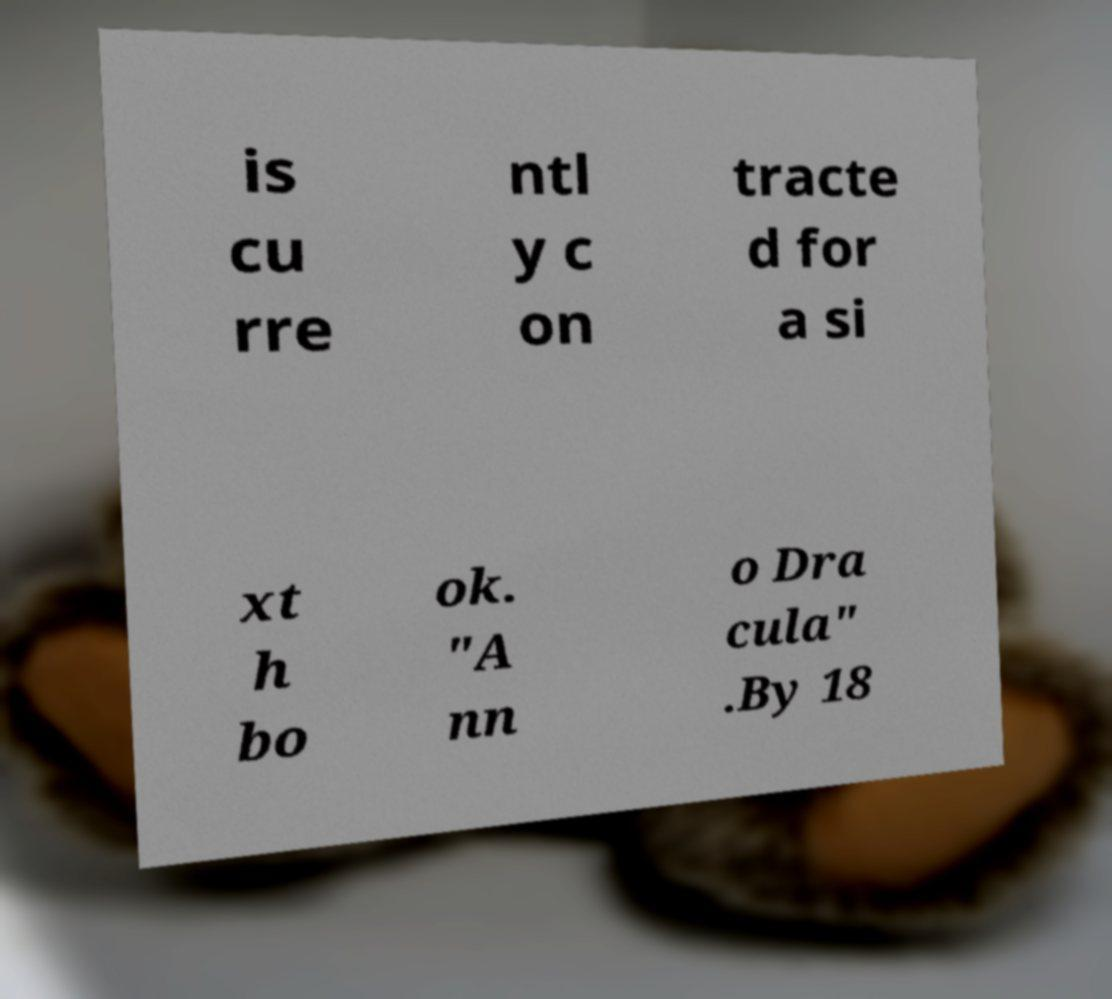Could you extract and type out the text from this image? is cu rre ntl y c on tracte d for a si xt h bo ok. "A nn o Dra cula" .By 18 